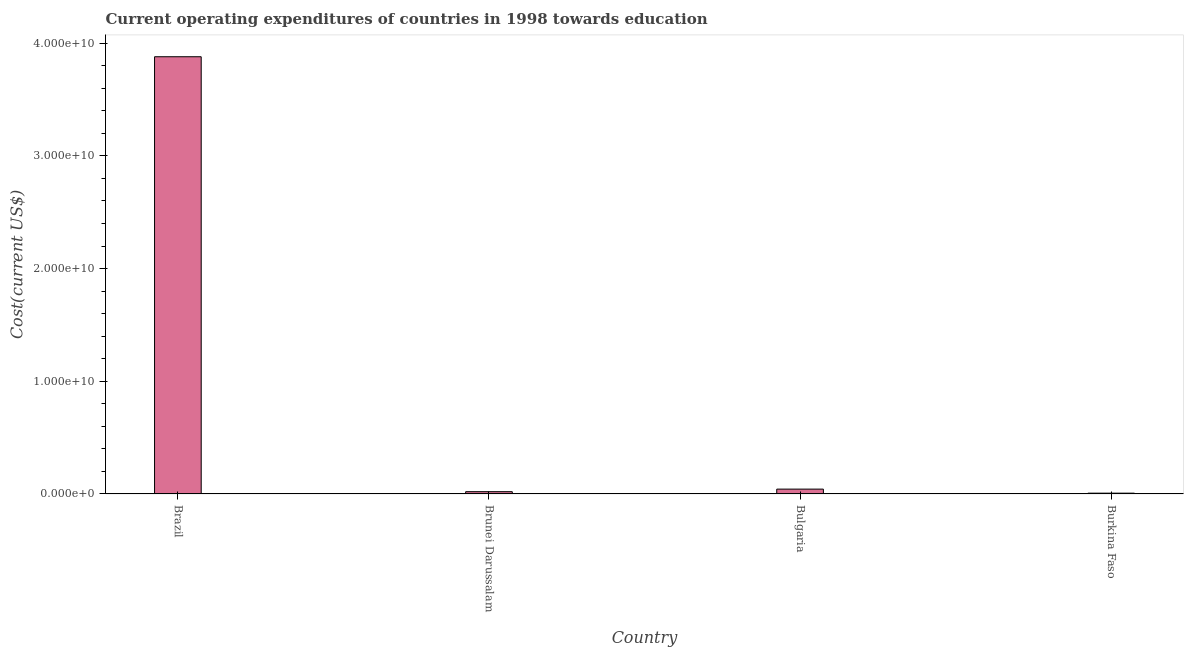Does the graph contain grids?
Provide a short and direct response. No. What is the title of the graph?
Provide a short and direct response. Current operating expenditures of countries in 1998 towards education. What is the label or title of the X-axis?
Provide a short and direct response. Country. What is the label or title of the Y-axis?
Make the answer very short. Cost(current US$). What is the education expenditure in Burkina Faso?
Keep it short and to the point. 7.15e+07. Across all countries, what is the maximum education expenditure?
Give a very brief answer. 3.88e+1. Across all countries, what is the minimum education expenditure?
Give a very brief answer. 7.15e+07. In which country was the education expenditure minimum?
Make the answer very short. Burkina Faso. What is the sum of the education expenditure?
Provide a short and direct response. 3.95e+1. What is the difference between the education expenditure in Brazil and Brunei Darussalam?
Offer a very short reply. 3.86e+1. What is the average education expenditure per country?
Offer a terse response. 9.88e+09. What is the median education expenditure?
Provide a short and direct response. 3.16e+08. In how many countries, is the education expenditure greater than 8000000000 US$?
Your answer should be very brief. 1. What is the ratio of the education expenditure in Bulgaria to that in Burkina Faso?
Provide a short and direct response. 6.02. What is the difference between the highest and the second highest education expenditure?
Offer a terse response. 3.84e+1. Is the sum of the education expenditure in Bulgaria and Burkina Faso greater than the maximum education expenditure across all countries?
Keep it short and to the point. No. What is the difference between the highest and the lowest education expenditure?
Provide a short and direct response. 3.87e+1. How many bars are there?
Offer a very short reply. 4. Are all the bars in the graph horizontal?
Keep it short and to the point. No. How many countries are there in the graph?
Offer a terse response. 4. What is the Cost(current US$) of Brazil?
Ensure brevity in your answer.  3.88e+1. What is the Cost(current US$) in Brunei Darussalam?
Give a very brief answer. 2.03e+08. What is the Cost(current US$) in Bulgaria?
Your response must be concise. 4.30e+08. What is the Cost(current US$) in Burkina Faso?
Your response must be concise. 7.15e+07. What is the difference between the Cost(current US$) in Brazil and Brunei Darussalam?
Provide a succinct answer. 3.86e+1. What is the difference between the Cost(current US$) in Brazil and Bulgaria?
Ensure brevity in your answer.  3.84e+1. What is the difference between the Cost(current US$) in Brazil and Burkina Faso?
Provide a short and direct response. 3.87e+1. What is the difference between the Cost(current US$) in Brunei Darussalam and Bulgaria?
Offer a very short reply. -2.28e+08. What is the difference between the Cost(current US$) in Brunei Darussalam and Burkina Faso?
Your response must be concise. 1.31e+08. What is the difference between the Cost(current US$) in Bulgaria and Burkina Faso?
Give a very brief answer. 3.59e+08. What is the ratio of the Cost(current US$) in Brazil to that in Brunei Darussalam?
Offer a very short reply. 191.55. What is the ratio of the Cost(current US$) in Brazil to that in Bulgaria?
Give a very brief answer. 90.14. What is the ratio of the Cost(current US$) in Brazil to that in Burkina Faso?
Keep it short and to the point. 543. What is the ratio of the Cost(current US$) in Brunei Darussalam to that in Bulgaria?
Make the answer very short. 0.47. What is the ratio of the Cost(current US$) in Brunei Darussalam to that in Burkina Faso?
Your answer should be very brief. 2.83. What is the ratio of the Cost(current US$) in Bulgaria to that in Burkina Faso?
Offer a terse response. 6.02. 